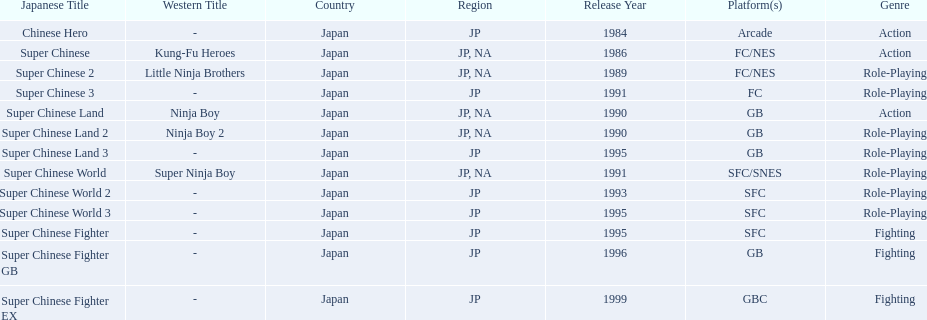What are the total of super chinese games released? 13. 